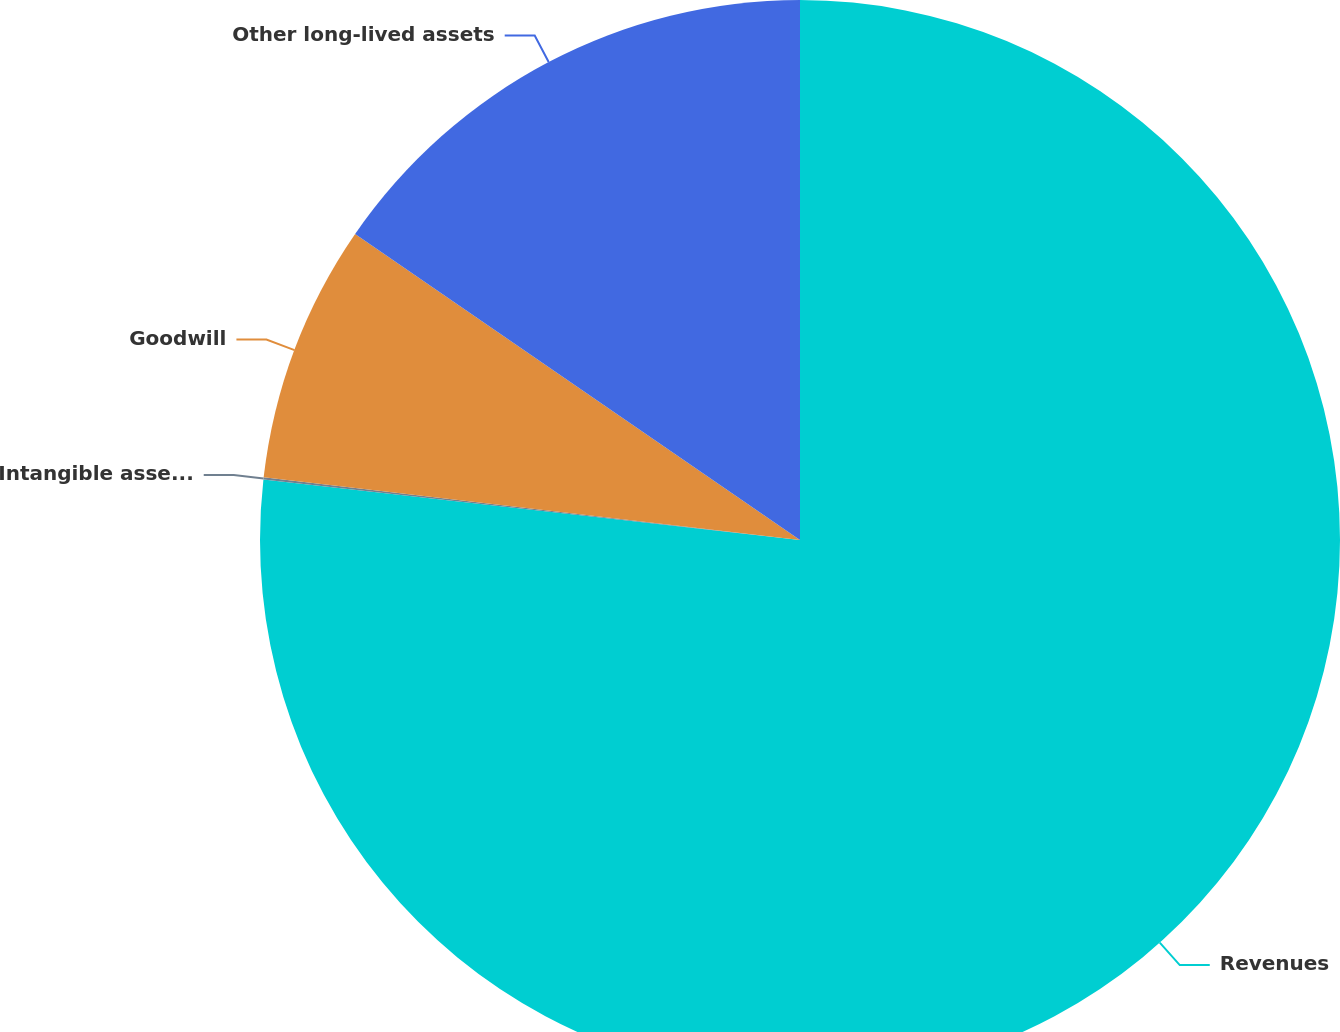Convert chart. <chart><loc_0><loc_0><loc_500><loc_500><pie_chart><fcel>Revenues<fcel>Intangible assets net<fcel>Goodwill<fcel>Other long-lived assets<nl><fcel>76.79%<fcel>0.06%<fcel>7.74%<fcel>15.41%<nl></chart> 